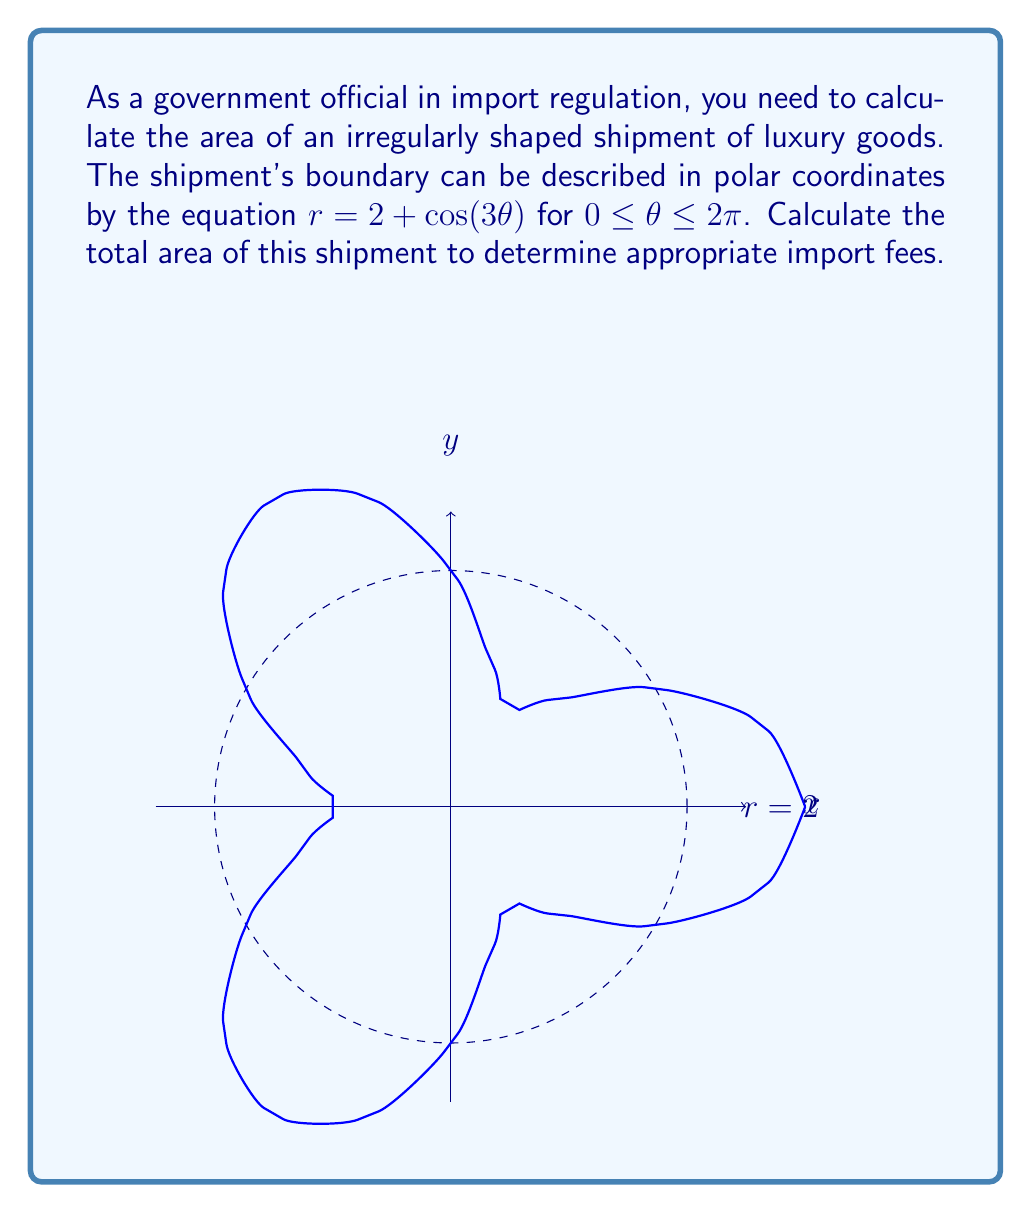Could you help me with this problem? To calculate the area of the shipment described by the polar equation $r = 2 + \cos(3\theta)$, we'll use the formula for area in polar coordinates:

$$A = \frac{1}{2} \int_0^{2\pi} r^2 d\theta$$

Step 1: Substitute the given equation into the area formula:
$$A = \frac{1}{2} \int_0^{2\pi} (2 + \cos(3\theta))^2 d\theta$$

Step 2: Expand the squared term:
$$A = \frac{1}{2} \int_0^{2\pi} (4 + 4\cos(3\theta) + \cos^2(3\theta)) d\theta$$

Step 3: Use the identity $\cos^2(x) = \frac{1}{2}(1 + \cos(2x))$:
$$A = \frac{1}{2} \int_0^{2\pi} (4 + 4\cos(3\theta) + \frac{1}{2}(1 + \cos(6\theta))) d\theta$$

Step 4: Simplify:
$$A = \frac{1}{2} \int_0^{2\pi} (4.5 + 4\cos(3\theta) + \frac{1}{2}\cos(6\theta)) d\theta$$

Step 5: Integrate each term:
$$A = \frac{1}{2} [4.5\theta + \frac{4}{3}\sin(3\theta) + \frac{1}{12}\sin(6\theta)]_0^{2\pi}$$

Step 6: Evaluate the definite integral:
$$A = \frac{1}{2} [(4.5 \cdot 2\pi + 0 + 0) - (0 + 0 + 0)]$$

Step 7: Simplify:
$$A = \frac{1}{2} \cdot 4.5 \cdot 2\pi = 4.5\pi$$
Answer: $4.5\pi$ square units 